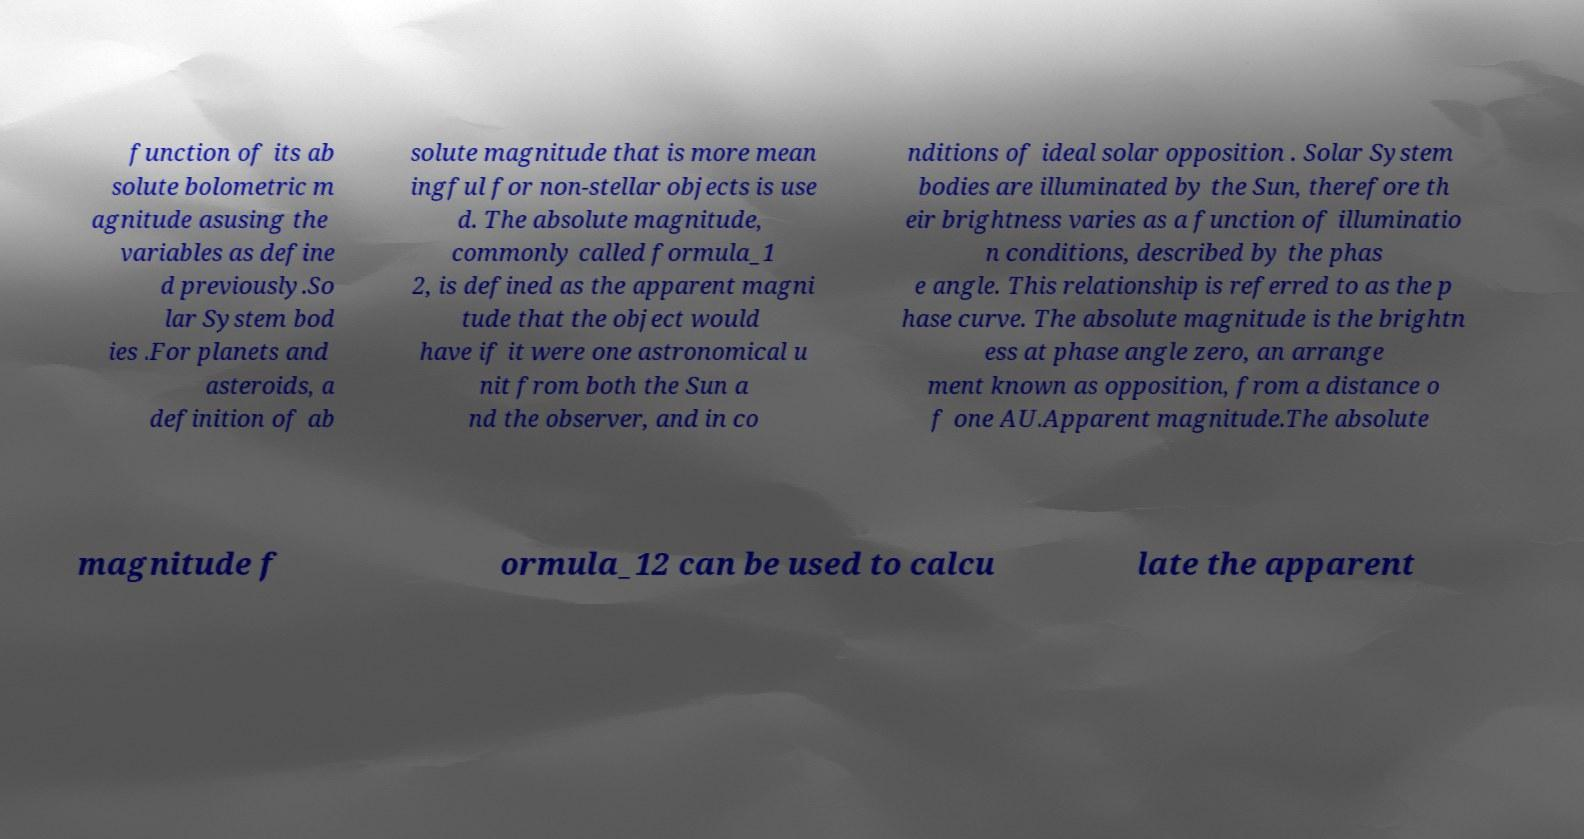For documentation purposes, I need the text within this image transcribed. Could you provide that? function of its ab solute bolometric m agnitude asusing the variables as define d previously.So lar System bod ies .For planets and asteroids, a definition of ab solute magnitude that is more mean ingful for non-stellar objects is use d. The absolute magnitude, commonly called formula_1 2, is defined as the apparent magni tude that the object would have if it were one astronomical u nit from both the Sun a nd the observer, and in co nditions of ideal solar opposition . Solar System bodies are illuminated by the Sun, therefore th eir brightness varies as a function of illuminatio n conditions, described by the phas e angle. This relationship is referred to as the p hase curve. The absolute magnitude is the brightn ess at phase angle zero, an arrange ment known as opposition, from a distance o f one AU.Apparent magnitude.The absolute magnitude f ormula_12 can be used to calcu late the apparent 